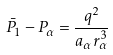<formula> <loc_0><loc_0><loc_500><loc_500>\bar { P } _ { 1 } - P _ { \alpha } = \frac { q ^ { 2 } } { a _ { \alpha } r _ { \alpha } ^ { 3 } }</formula> 